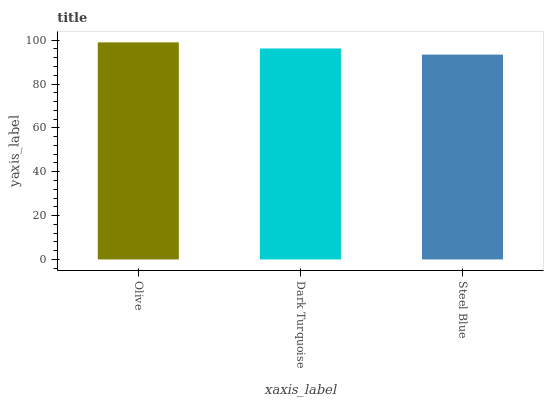Is Steel Blue the minimum?
Answer yes or no. Yes. Is Olive the maximum?
Answer yes or no. Yes. Is Dark Turquoise the minimum?
Answer yes or no. No. Is Dark Turquoise the maximum?
Answer yes or no. No. Is Olive greater than Dark Turquoise?
Answer yes or no. Yes. Is Dark Turquoise less than Olive?
Answer yes or no. Yes. Is Dark Turquoise greater than Olive?
Answer yes or no. No. Is Olive less than Dark Turquoise?
Answer yes or no. No. Is Dark Turquoise the high median?
Answer yes or no. Yes. Is Dark Turquoise the low median?
Answer yes or no. Yes. Is Olive the high median?
Answer yes or no. No. Is Olive the low median?
Answer yes or no. No. 